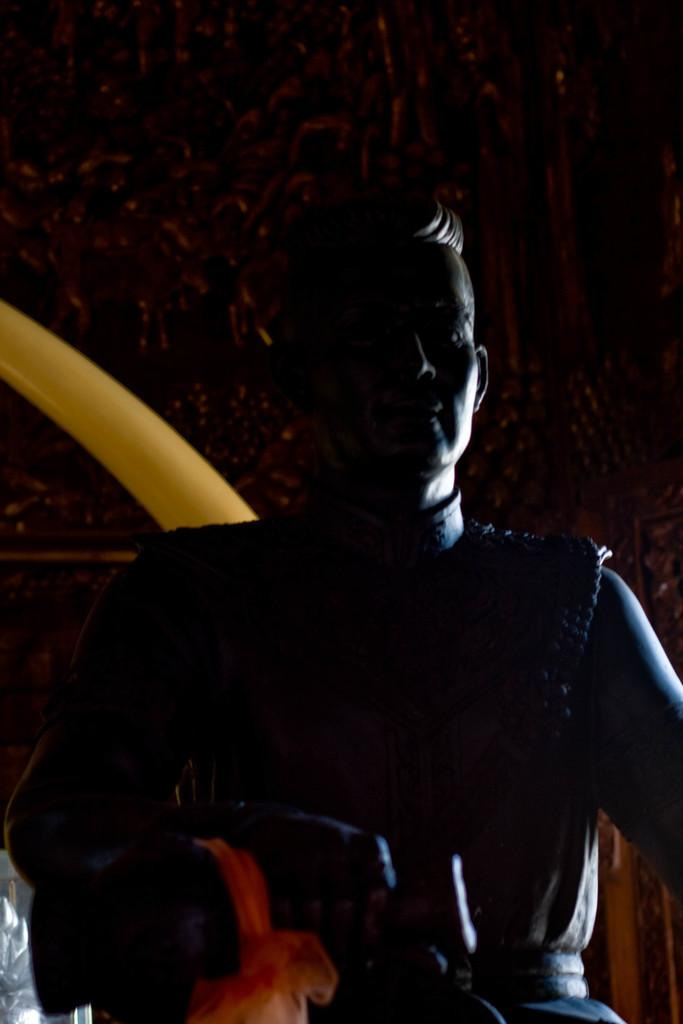What is the main subject in the image? There is a statue in the image. What can be seen in the background of the image? There are sculptures on the wall in the background. What color is one of the objects in the image? There is a yellow colored object in the image. Where is an object located in the image? There is an object on the bottom left of the image. How does the statue's finger affect the poison in the image? There is no mention of fingers or poison in the image; the statue and sculptures are the main subjects. 